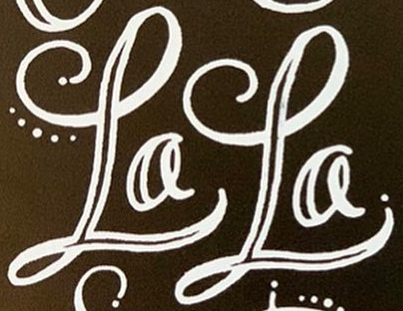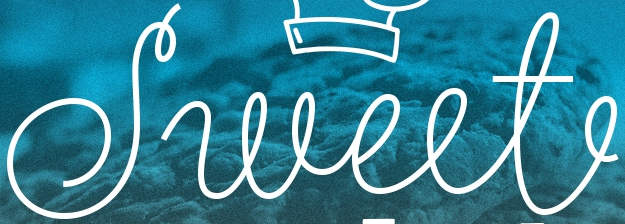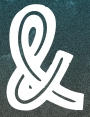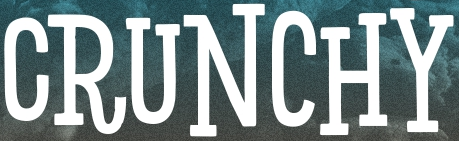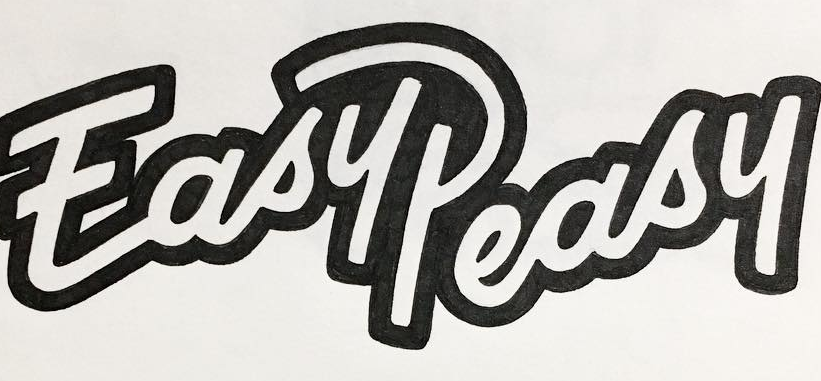Identify the words shown in these images in order, separated by a semicolon. LaLa; Sweet; &; CRUNCHY; EasyPeasy 